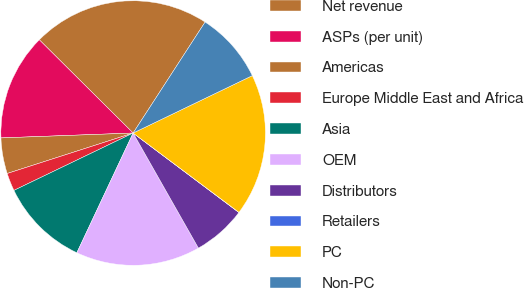<chart> <loc_0><loc_0><loc_500><loc_500><pie_chart><fcel>Net revenue<fcel>ASPs (per unit)<fcel>Americas<fcel>Europe Middle East and Africa<fcel>Asia<fcel>OEM<fcel>Distributors<fcel>Retailers<fcel>PC<fcel>Non-PC<nl><fcel>21.71%<fcel>13.04%<fcel>4.36%<fcel>2.19%<fcel>10.87%<fcel>15.21%<fcel>6.53%<fcel>0.02%<fcel>17.38%<fcel>8.7%<nl></chart> 